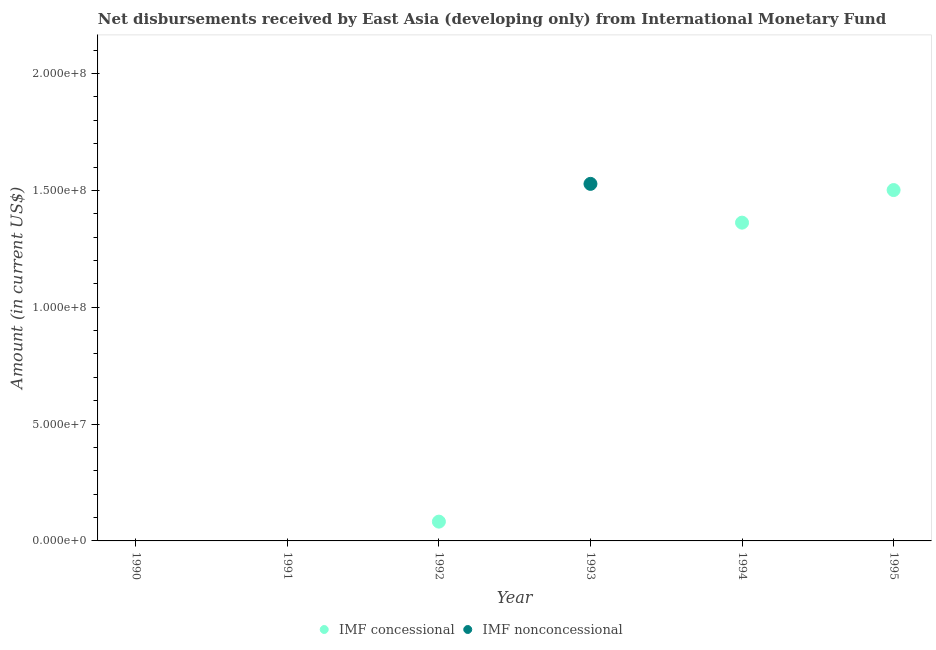Is the number of dotlines equal to the number of legend labels?
Ensure brevity in your answer.  No. Across all years, what is the maximum net non concessional disbursements from imf?
Your response must be concise. 1.53e+08. Across all years, what is the minimum net non concessional disbursements from imf?
Offer a terse response. 0. In which year was the net concessional disbursements from imf maximum?
Keep it short and to the point. 1995. What is the total net concessional disbursements from imf in the graph?
Your response must be concise. 2.95e+08. What is the difference between the net concessional disbursements from imf in 1992 and that in 1994?
Ensure brevity in your answer.  -1.28e+08. What is the difference between the net non concessional disbursements from imf in 1992 and the net concessional disbursements from imf in 1995?
Offer a terse response. -1.50e+08. What is the average net concessional disbursements from imf per year?
Give a very brief answer. 4.91e+07. What is the difference between the highest and the second highest net concessional disbursements from imf?
Provide a succinct answer. 1.39e+07. What is the difference between the highest and the lowest net non concessional disbursements from imf?
Your answer should be very brief. 1.53e+08. Is the sum of the net concessional disbursements from imf in 1994 and 1995 greater than the maximum net non concessional disbursements from imf across all years?
Offer a terse response. Yes. Does the net non concessional disbursements from imf monotonically increase over the years?
Offer a very short reply. No. Is the net non concessional disbursements from imf strictly greater than the net concessional disbursements from imf over the years?
Make the answer very short. No. Is the net concessional disbursements from imf strictly less than the net non concessional disbursements from imf over the years?
Your answer should be compact. No. How many dotlines are there?
Give a very brief answer. 2. Where does the legend appear in the graph?
Give a very brief answer. Bottom center. How many legend labels are there?
Your answer should be compact. 2. How are the legend labels stacked?
Offer a terse response. Horizontal. What is the title of the graph?
Offer a very short reply. Net disbursements received by East Asia (developing only) from International Monetary Fund. What is the label or title of the X-axis?
Offer a very short reply. Year. What is the label or title of the Y-axis?
Ensure brevity in your answer.  Amount (in current US$). What is the Amount (in current US$) of IMF nonconcessional in 1990?
Give a very brief answer. 0. What is the Amount (in current US$) in IMF concessional in 1991?
Your answer should be compact. 0. What is the Amount (in current US$) in IMF nonconcessional in 1991?
Your answer should be compact. 0. What is the Amount (in current US$) in IMF concessional in 1992?
Offer a very short reply. 8.25e+06. What is the Amount (in current US$) of IMF nonconcessional in 1992?
Ensure brevity in your answer.  0. What is the Amount (in current US$) of IMF concessional in 1993?
Your answer should be compact. 0. What is the Amount (in current US$) in IMF nonconcessional in 1993?
Keep it short and to the point. 1.53e+08. What is the Amount (in current US$) in IMF concessional in 1994?
Ensure brevity in your answer.  1.36e+08. What is the Amount (in current US$) in IMF nonconcessional in 1994?
Provide a short and direct response. 0. What is the Amount (in current US$) of IMF concessional in 1995?
Make the answer very short. 1.50e+08. Across all years, what is the maximum Amount (in current US$) of IMF concessional?
Provide a short and direct response. 1.50e+08. Across all years, what is the maximum Amount (in current US$) of IMF nonconcessional?
Keep it short and to the point. 1.53e+08. Across all years, what is the minimum Amount (in current US$) of IMF concessional?
Provide a short and direct response. 0. What is the total Amount (in current US$) in IMF concessional in the graph?
Give a very brief answer. 2.95e+08. What is the total Amount (in current US$) of IMF nonconcessional in the graph?
Your answer should be very brief. 1.53e+08. What is the difference between the Amount (in current US$) of IMF concessional in 1992 and that in 1994?
Your answer should be compact. -1.28e+08. What is the difference between the Amount (in current US$) of IMF concessional in 1992 and that in 1995?
Your response must be concise. -1.42e+08. What is the difference between the Amount (in current US$) of IMF concessional in 1994 and that in 1995?
Your answer should be very brief. -1.39e+07. What is the difference between the Amount (in current US$) in IMF concessional in 1992 and the Amount (in current US$) in IMF nonconcessional in 1993?
Offer a very short reply. -1.45e+08. What is the average Amount (in current US$) in IMF concessional per year?
Offer a very short reply. 4.91e+07. What is the average Amount (in current US$) of IMF nonconcessional per year?
Your response must be concise. 2.55e+07. What is the ratio of the Amount (in current US$) in IMF concessional in 1992 to that in 1994?
Provide a succinct answer. 0.06. What is the ratio of the Amount (in current US$) of IMF concessional in 1992 to that in 1995?
Offer a very short reply. 0.06. What is the ratio of the Amount (in current US$) in IMF concessional in 1994 to that in 1995?
Your answer should be compact. 0.91. What is the difference between the highest and the second highest Amount (in current US$) of IMF concessional?
Provide a short and direct response. 1.39e+07. What is the difference between the highest and the lowest Amount (in current US$) of IMF concessional?
Keep it short and to the point. 1.50e+08. What is the difference between the highest and the lowest Amount (in current US$) in IMF nonconcessional?
Offer a very short reply. 1.53e+08. 